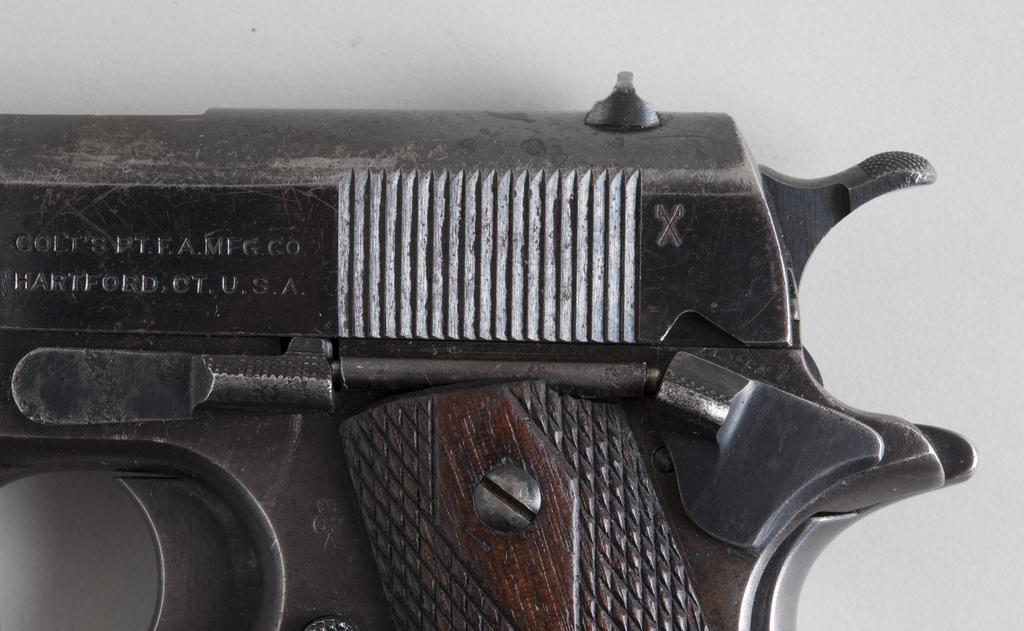What object is the main subject of the image? There is a pistol in the image. What is the color of the pistol? The pistol is black in color. On what surface is the pistol placed? The pistol is placed on a white surface. How many babies are holding the pistol in the image? There are no babies present in the image, and therefore no one is holding the pistol. 